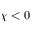Convert formula to latex. <formula><loc_0><loc_0><loc_500><loc_500>\chi < 0</formula> 